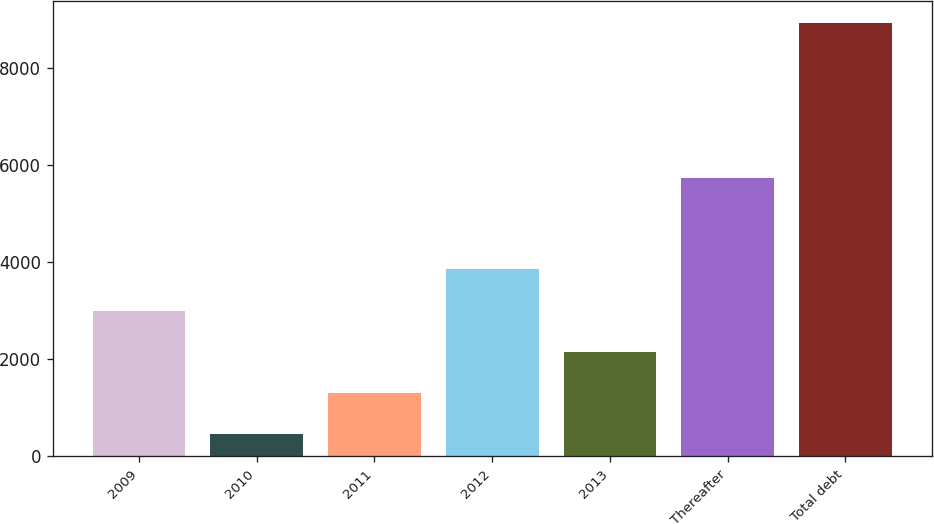Convert chart. <chart><loc_0><loc_0><loc_500><loc_500><bar_chart><fcel>2009<fcel>2010<fcel>2011<fcel>2012<fcel>2013<fcel>Thereafter<fcel>Total debt<nl><fcel>3003.6<fcel>465<fcel>1311.2<fcel>3849.8<fcel>2157.4<fcel>5728<fcel>8927<nl></chart> 